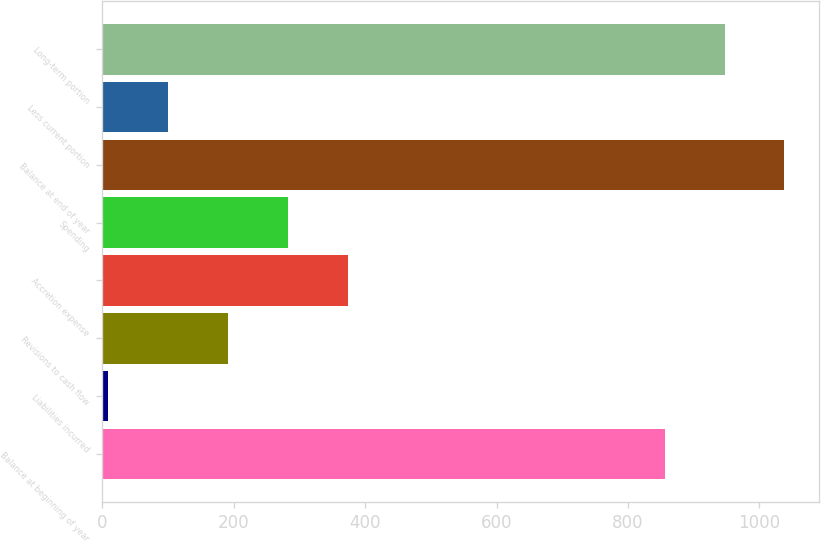Convert chart to OTSL. <chart><loc_0><loc_0><loc_500><loc_500><bar_chart><fcel>Balance at beginning of year<fcel>Liabilities incurred<fcel>Revisions to cash flow<fcel>Accretion expense<fcel>Spending<fcel>Balance at end of year<fcel>Less current portion<fcel>Long-term portion<nl><fcel>856<fcel>9<fcel>191.4<fcel>373.8<fcel>282.6<fcel>1038.4<fcel>100.2<fcel>947.2<nl></chart> 